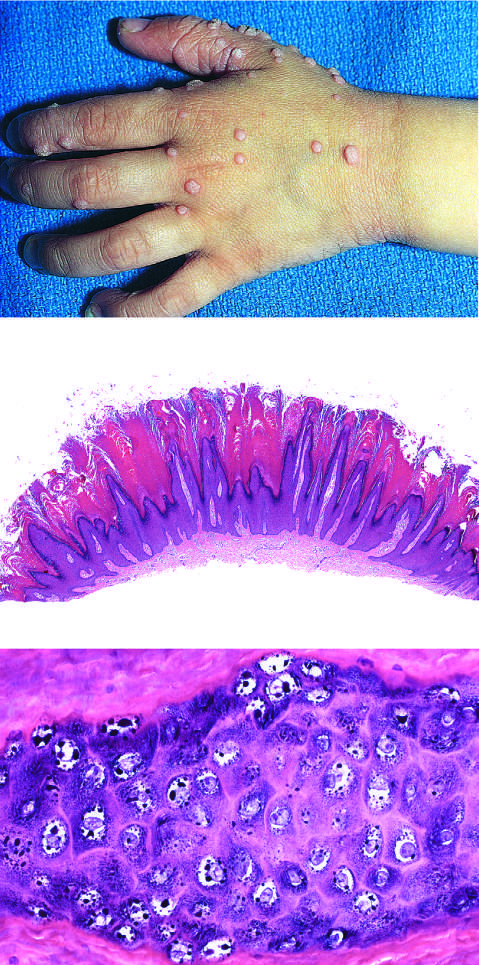what contain zones of papillary epidermal proliferation that often radiate symmetrically like the points of a crown?
Answer the question using a single word or phrase. Common warts 